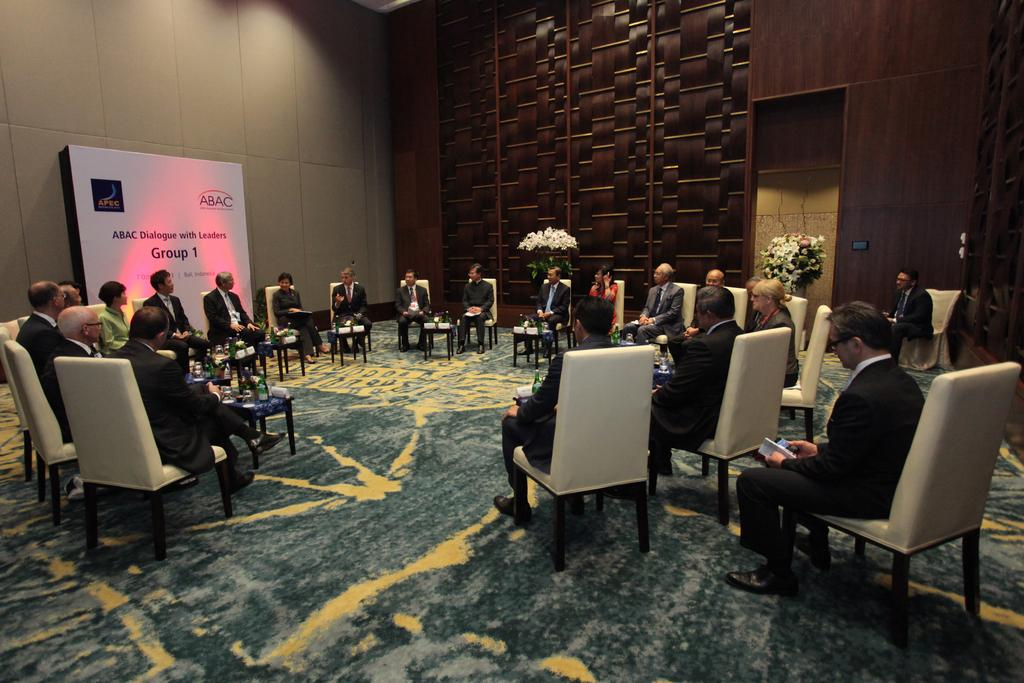What are the people in the image doing? The people in the image are sitting on chairs. What can be seen in the image besides the people sitting on chairs? There is a flower plant and a poster with the words "Group One" in the image. What are the people wearing in the image? The people are wearing blazers. Can you tell me how many kittens are playing in the wilderness in the image? There are no kittens or wilderness present in the image; it features people sitting on chairs, a flower plant, and a poster with the words "Group One." 